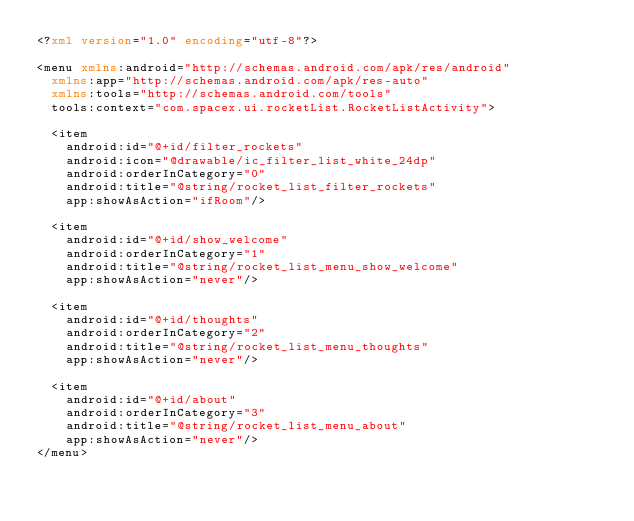<code> <loc_0><loc_0><loc_500><loc_500><_XML_><?xml version="1.0" encoding="utf-8"?>

<menu xmlns:android="http://schemas.android.com/apk/res/android"
  xmlns:app="http://schemas.android.com/apk/res-auto"
  xmlns:tools="http://schemas.android.com/tools"
  tools:context="com.spacex.ui.rocketList.RocketListActivity">

  <item
    android:id="@+id/filter_rockets"
    android:icon="@drawable/ic_filter_list_white_24dp"
    android:orderInCategory="0"
    android:title="@string/rocket_list_filter_rockets"
    app:showAsAction="ifRoom"/>

  <item
    android:id="@+id/show_welcome"
    android:orderInCategory="1"
    android:title="@string/rocket_list_menu_show_welcome"
    app:showAsAction="never"/>

  <item
    android:id="@+id/thoughts"
    android:orderInCategory="2"
    android:title="@string/rocket_list_menu_thoughts"
    app:showAsAction="never"/>

  <item
    android:id="@+id/about"
    android:orderInCategory="3"
    android:title="@string/rocket_list_menu_about"
    app:showAsAction="never"/>
</menu>
</code> 